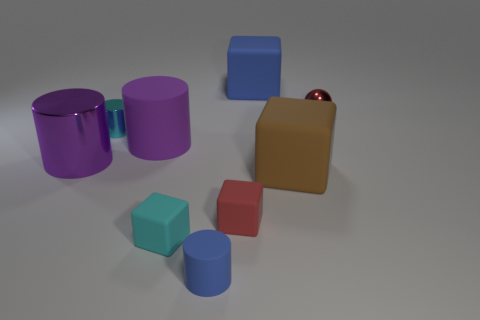There is a cube to the left of the red object left of the tiny metal sphere; is there a red object to the left of it? No, there is not a red object to the left of the cube mentioned. To the left of the cube, there is a larger blue cube. 